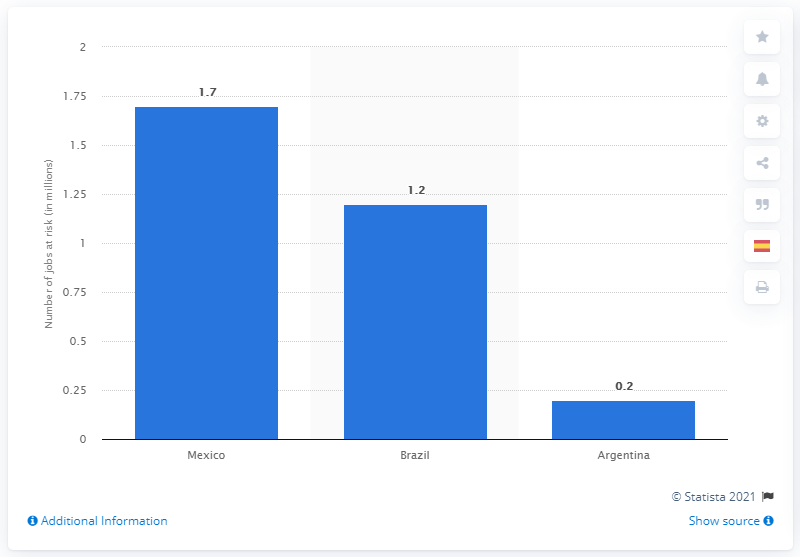Draw attention to some important aspects in this diagram. Argentina's tourism sector could potentially lose up to 0.2 jobs. The COVID-19 pandemic could potentially endanger 1.7 jobs in Mexico alone. The most populous country in Latin America is Brazil. 